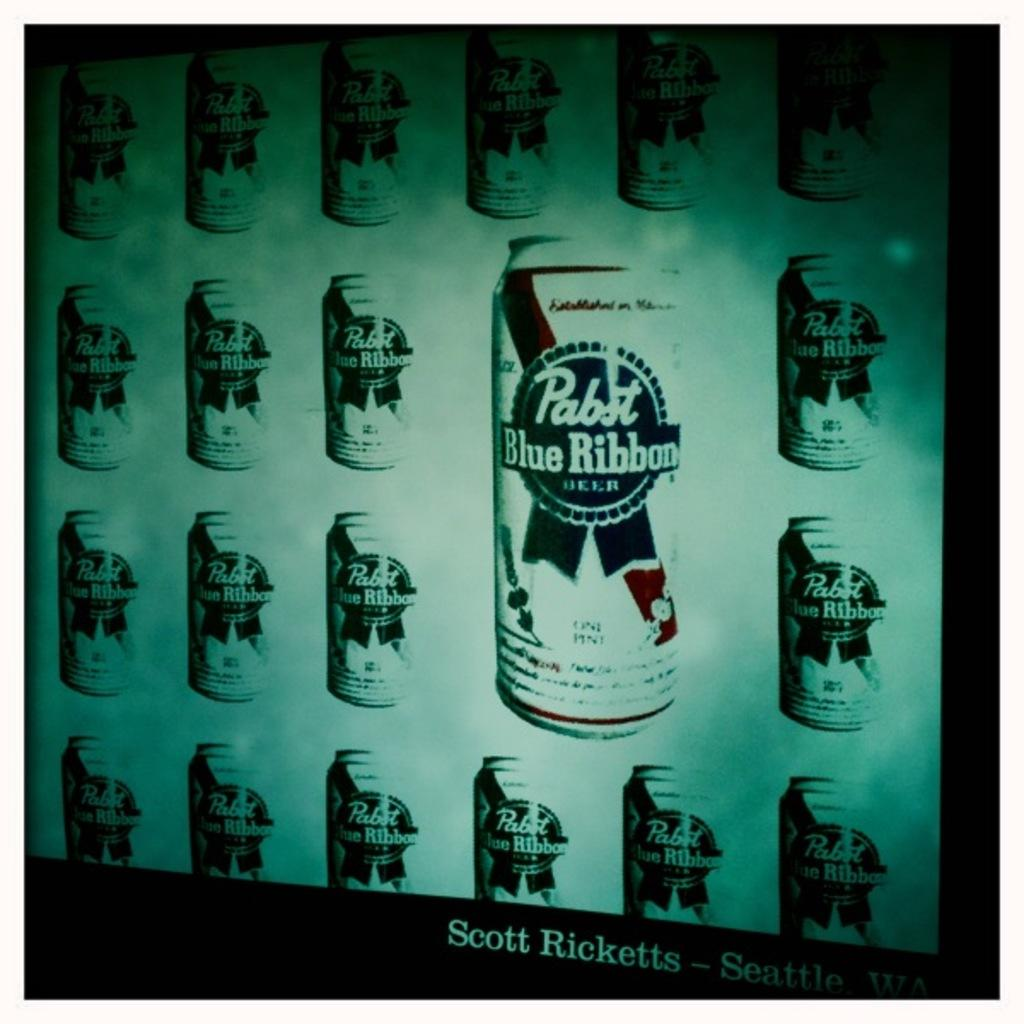<image>
Summarize the visual content of the image. A Andy Warhol style pop-art print of Pabst Blue Ribbon beer cans 